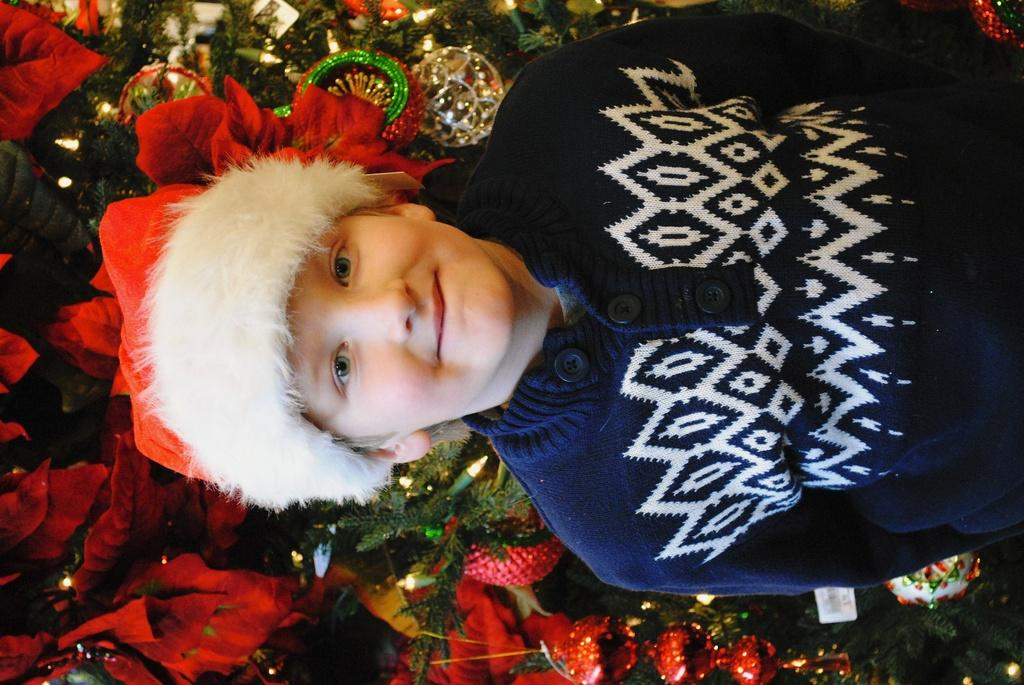Who is present in the image? There is a man in the image. What is the man wearing on his head? The man is wearing a hat. What color is the jacket the man is wearing? The man is wearing a blue jacket. What type of natural elements can be seen in the image? There are leaves visible in the image. What time of day is the man embarking on his scientific voyage in the image? There is no indication of a scientific voyage or a specific time of day in the image. The image only shows a man wearing a hat and a blue jacket, with leaves visible in the background. 